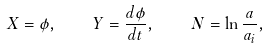Convert formula to latex. <formula><loc_0><loc_0><loc_500><loc_500>X = \phi , \quad Y = \frac { d \phi } { d t } , \quad N = \ln \frac { a } { a _ { i } } ,</formula> 